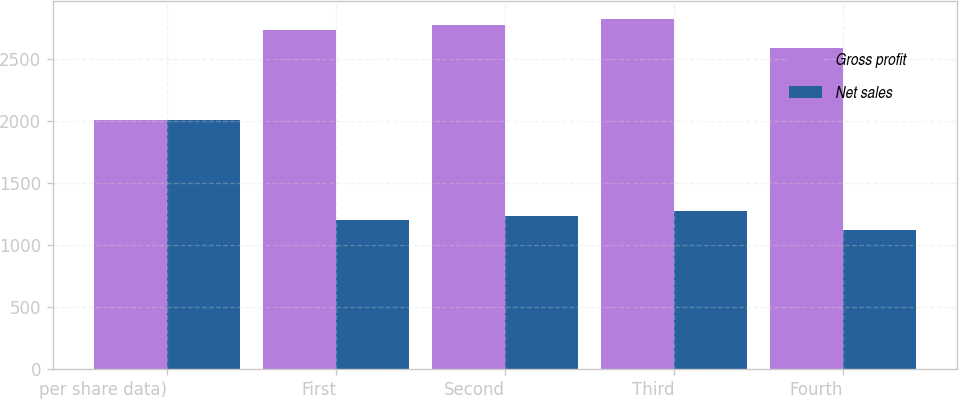Convert chart to OTSL. <chart><loc_0><loc_0><loc_500><loc_500><stacked_bar_chart><ecel><fcel>per share data)<fcel>First<fcel>Second<fcel>Third<fcel>Fourth<nl><fcel>Gross profit<fcel>2006<fcel>2726.5<fcel>2773.9<fcel>2822.4<fcel>2583.9<nl><fcel>Net sales<fcel>2006<fcel>1196.7<fcel>1235.5<fcel>1273.3<fcel>1119.7<nl></chart> 